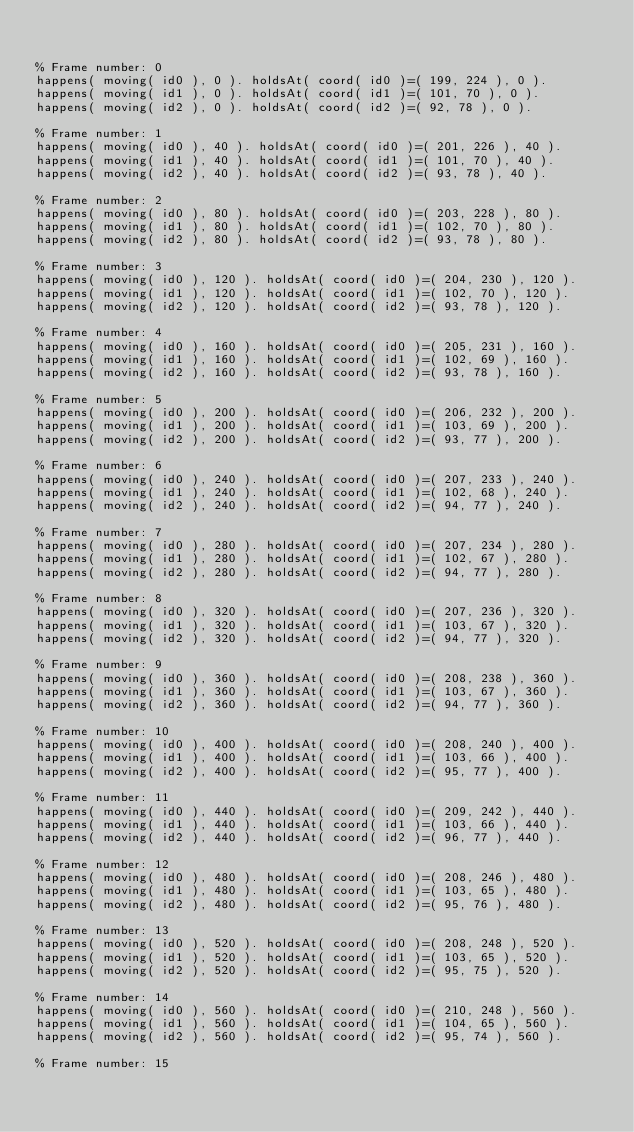<code> <loc_0><loc_0><loc_500><loc_500><_Perl_>

% Frame number: 0
happens( moving( id0 ), 0 ). holdsAt( coord( id0 )=( 199, 224 ), 0 ).
happens( moving( id1 ), 0 ). holdsAt( coord( id1 )=( 101, 70 ), 0 ).
happens( moving( id2 ), 0 ). holdsAt( coord( id2 )=( 92, 78 ), 0 ).

% Frame number: 1
happens( moving( id0 ), 40 ). holdsAt( coord( id0 )=( 201, 226 ), 40 ).
happens( moving( id1 ), 40 ). holdsAt( coord( id1 )=( 101, 70 ), 40 ).
happens( moving( id2 ), 40 ). holdsAt( coord( id2 )=( 93, 78 ), 40 ).

% Frame number: 2
happens( moving( id0 ), 80 ). holdsAt( coord( id0 )=( 203, 228 ), 80 ).
happens( moving( id1 ), 80 ). holdsAt( coord( id1 )=( 102, 70 ), 80 ).
happens( moving( id2 ), 80 ). holdsAt( coord( id2 )=( 93, 78 ), 80 ).

% Frame number: 3
happens( moving( id0 ), 120 ). holdsAt( coord( id0 )=( 204, 230 ), 120 ).
happens( moving( id1 ), 120 ). holdsAt( coord( id1 )=( 102, 70 ), 120 ).
happens( moving( id2 ), 120 ). holdsAt( coord( id2 )=( 93, 78 ), 120 ).

% Frame number: 4
happens( moving( id0 ), 160 ). holdsAt( coord( id0 )=( 205, 231 ), 160 ).
happens( moving( id1 ), 160 ). holdsAt( coord( id1 )=( 102, 69 ), 160 ).
happens( moving( id2 ), 160 ). holdsAt( coord( id2 )=( 93, 78 ), 160 ).

% Frame number: 5
happens( moving( id0 ), 200 ). holdsAt( coord( id0 )=( 206, 232 ), 200 ).
happens( moving( id1 ), 200 ). holdsAt( coord( id1 )=( 103, 69 ), 200 ).
happens( moving( id2 ), 200 ). holdsAt( coord( id2 )=( 93, 77 ), 200 ).

% Frame number: 6
happens( moving( id0 ), 240 ). holdsAt( coord( id0 )=( 207, 233 ), 240 ).
happens( moving( id1 ), 240 ). holdsAt( coord( id1 )=( 102, 68 ), 240 ).
happens( moving( id2 ), 240 ). holdsAt( coord( id2 )=( 94, 77 ), 240 ).

% Frame number: 7
happens( moving( id0 ), 280 ). holdsAt( coord( id0 )=( 207, 234 ), 280 ).
happens( moving( id1 ), 280 ). holdsAt( coord( id1 )=( 102, 67 ), 280 ).
happens( moving( id2 ), 280 ). holdsAt( coord( id2 )=( 94, 77 ), 280 ).

% Frame number: 8
happens( moving( id0 ), 320 ). holdsAt( coord( id0 )=( 207, 236 ), 320 ).
happens( moving( id1 ), 320 ). holdsAt( coord( id1 )=( 103, 67 ), 320 ).
happens( moving( id2 ), 320 ). holdsAt( coord( id2 )=( 94, 77 ), 320 ).

% Frame number: 9
happens( moving( id0 ), 360 ). holdsAt( coord( id0 )=( 208, 238 ), 360 ).
happens( moving( id1 ), 360 ). holdsAt( coord( id1 )=( 103, 67 ), 360 ).
happens( moving( id2 ), 360 ). holdsAt( coord( id2 )=( 94, 77 ), 360 ).

% Frame number: 10
happens( moving( id0 ), 400 ). holdsAt( coord( id0 )=( 208, 240 ), 400 ).
happens( moving( id1 ), 400 ). holdsAt( coord( id1 )=( 103, 66 ), 400 ).
happens( moving( id2 ), 400 ). holdsAt( coord( id2 )=( 95, 77 ), 400 ).

% Frame number: 11
happens( moving( id0 ), 440 ). holdsAt( coord( id0 )=( 209, 242 ), 440 ).
happens( moving( id1 ), 440 ). holdsAt( coord( id1 )=( 103, 66 ), 440 ).
happens( moving( id2 ), 440 ). holdsAt( coord( id2 )=( 96, 77 ), 440 ).

% Frame number: 12
happens( moving( id0 ), 480 ). holdsAt( coord( id0 )=( 208, 246 ), 480 ).
happens( moving( id1 ), 480 ). holdsAt( coord( id1 )=( 103, 65 ), 480 ).
happens( moving( id2 ), 480 ). holdsAt( coord( id2 )=( 95, 76 ), 480 ).

% Frame number: 13
happens( moving( id0 ), 520 ). holdsAt( coord( id0 )=( 208, 248 ), 520 ).
happens( moving( id1 ), 520 ). holdsAt( coord( id1 )=( 103, 65 ), 520 ).
happens( moving( id2 ), 520 ). holdsAt( coord( id2 )=( 95, 75 ), 520 ).

% Frame number: 14
happens( moving( id0 ), 560 ). holdsAt( coord( id0 )=( 210, 248 ), 560 ).
happens( moving( id1 ), 560 ). holdsAt( coord( id1 )=( 104, 65 ), 560 ).
happens( moving( id2 ), 560 ). holdsAt( coord( id2 )=( 95, 74 ), 560 ).

% Frame number: 15</code> 